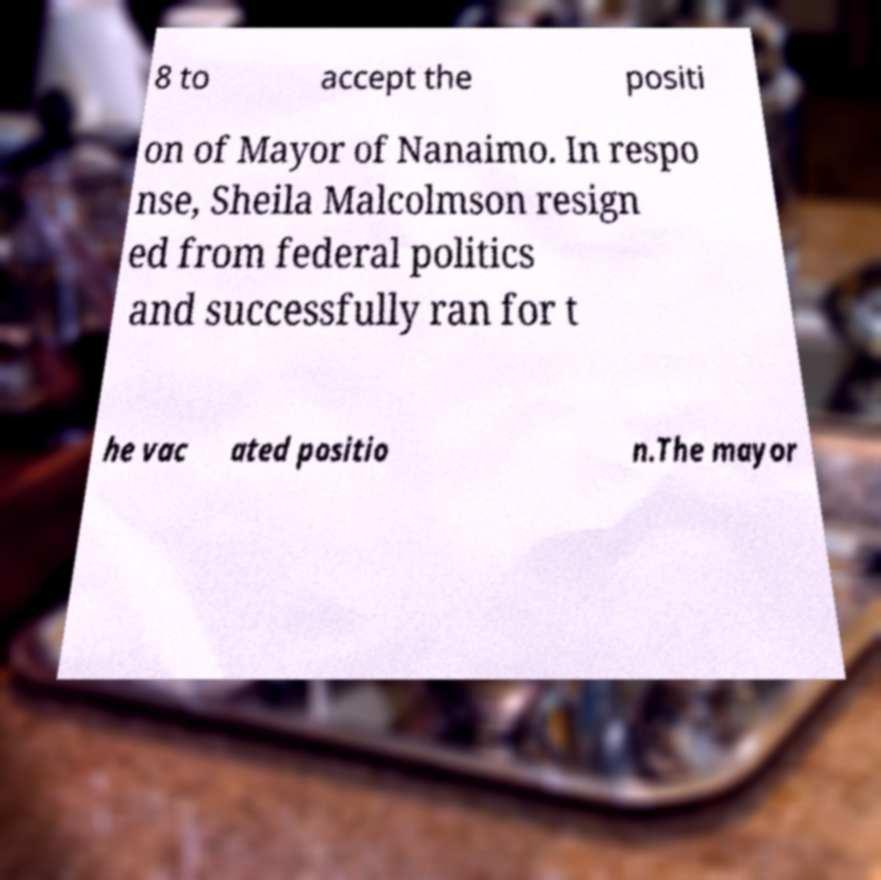What messages or text are displayed in this image? I need them in a readable, typed format. 8 to accept the positi on of Mayor of Nanaimo. In respo nse, Sheila Malcolmson resign ed from federal politics and successfully ran for t he vac ated positio n.The mayor 